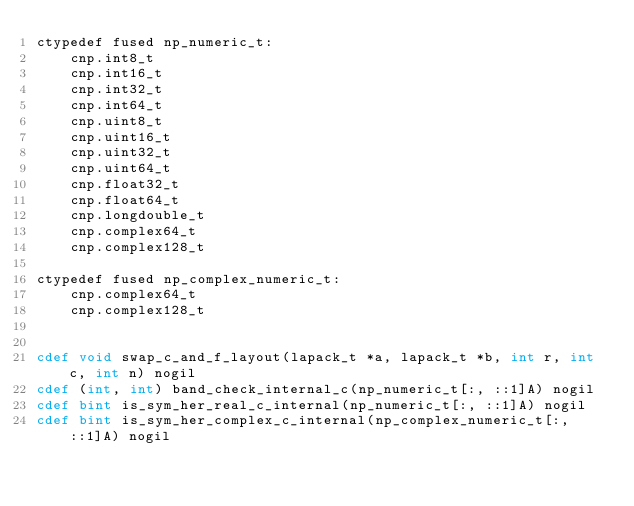<code> <loc_0><loc_0><loc_500><loc_500><_Cython_>ctypedef fused np_numeric_t:
    cnp.int8_t
    cnp.int16_t
    cnp.int32_t
    cnp.int64_t
    cnp.uint8_t
    cnp.uint16_t
    cnp.uint32_t
    cnp.uint64_t
    cnp.float32_t
    cnp.float64_t
    cnp.longdouble_t
    cnp.complex64_t
    cnp.complex128_t

ctypedef fused np_complex_numeric_t:
    cnp.complex64_t
    cnp.complex128_t


cdef void swap_c_and_f_layout(lapack_t *a, lapack_t *b, int r, int c, int n) nogil
cdef (int, int) band_check_internal_c(np_numeric_t[:, ::1]A) nogil
cdef bint is_sym_her_real_c_internal(np_numeric_t[:, ::1]A) nogil
cdef bint is_sym_her_complex_c_internal(np_complex_numeric_t[:, ::1]A) nogil
</code> 